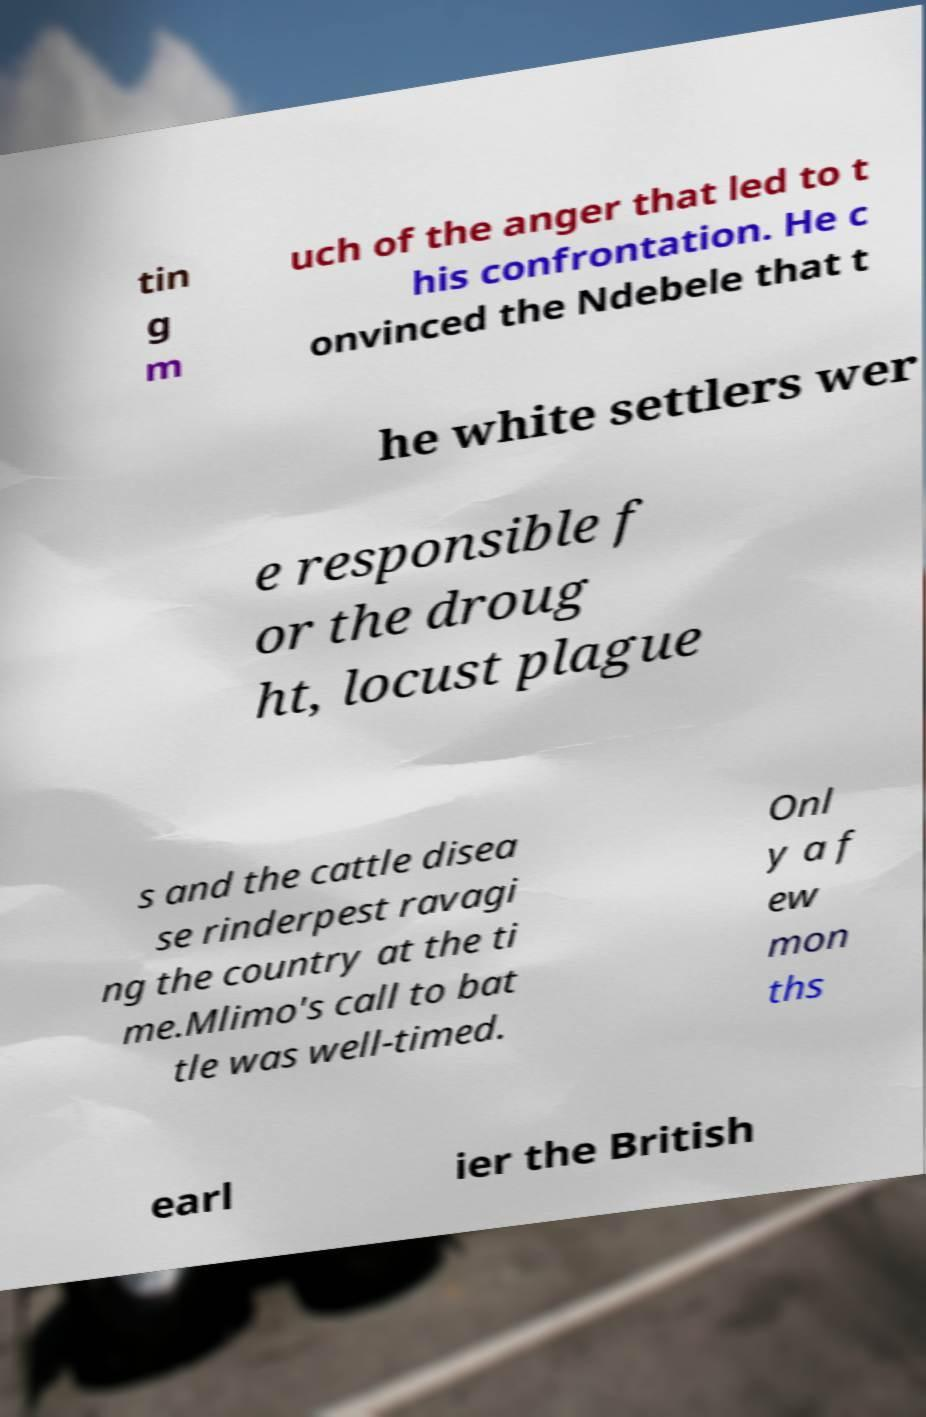For documentation purposes, I need the text within this image transcribed. Could you provide that? tin g m uch of the anger that led to t his confrontation. He c onvinced the Ndebele that t he white settlers wer e responsible f or the droug ht, locust plague s and the cattle disea se rinderpest ravagi ng the country at the ti me.Mlimo's call to bat tle was well-timed. Onl y a f ew mon ths earl ier the British 